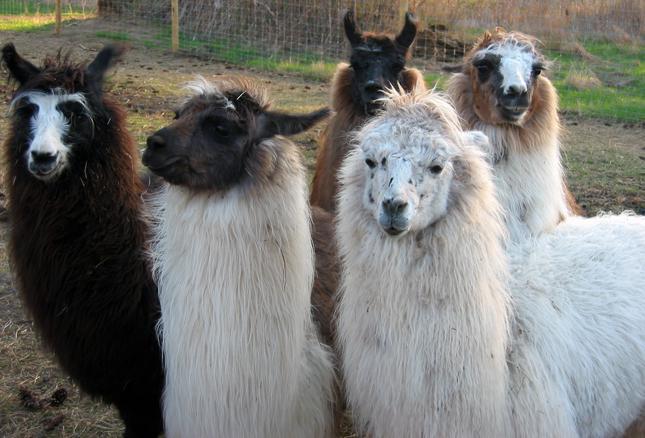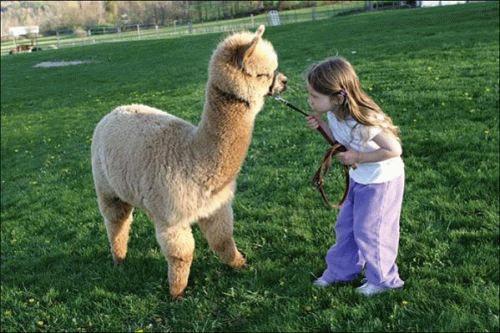The first image is the image on the left, the second image is the image on the right. Considering the images on both sides, is "At least one person is standing outside with the animals in one of the images." valid? Answer yes or no. Yes. The first image is the image on the left, the second image is the image on the right. Examine the images to the left and right. Is the description "One image shows a close-together group of several llamas with bodies turned forward, and the other image includes a person standing to the right of and looking at a llama while holding a rope attached to it." accurate? Answer yes or no. Yes. 